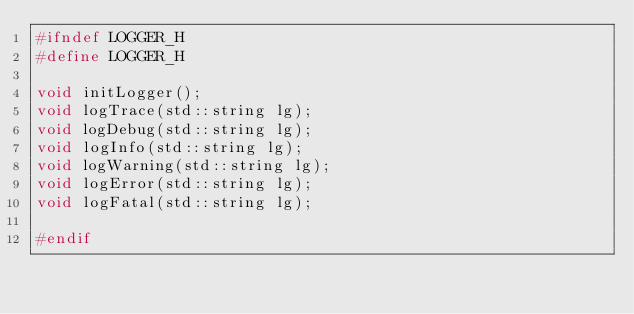Convert code to text. <code><loc_0><loc_0><loc_500><loc_500><_C_>#ifndef LOGGER_H
#define LOGGER_H

void initLogger();
void logTrace(std::string lg);
void logDebug(std::string lg);
void logInfo(std::string lg);
void logWarning(std::string lg);
void logError(std::string lg);
void logFatal(std::string lg);

#endif</code> 